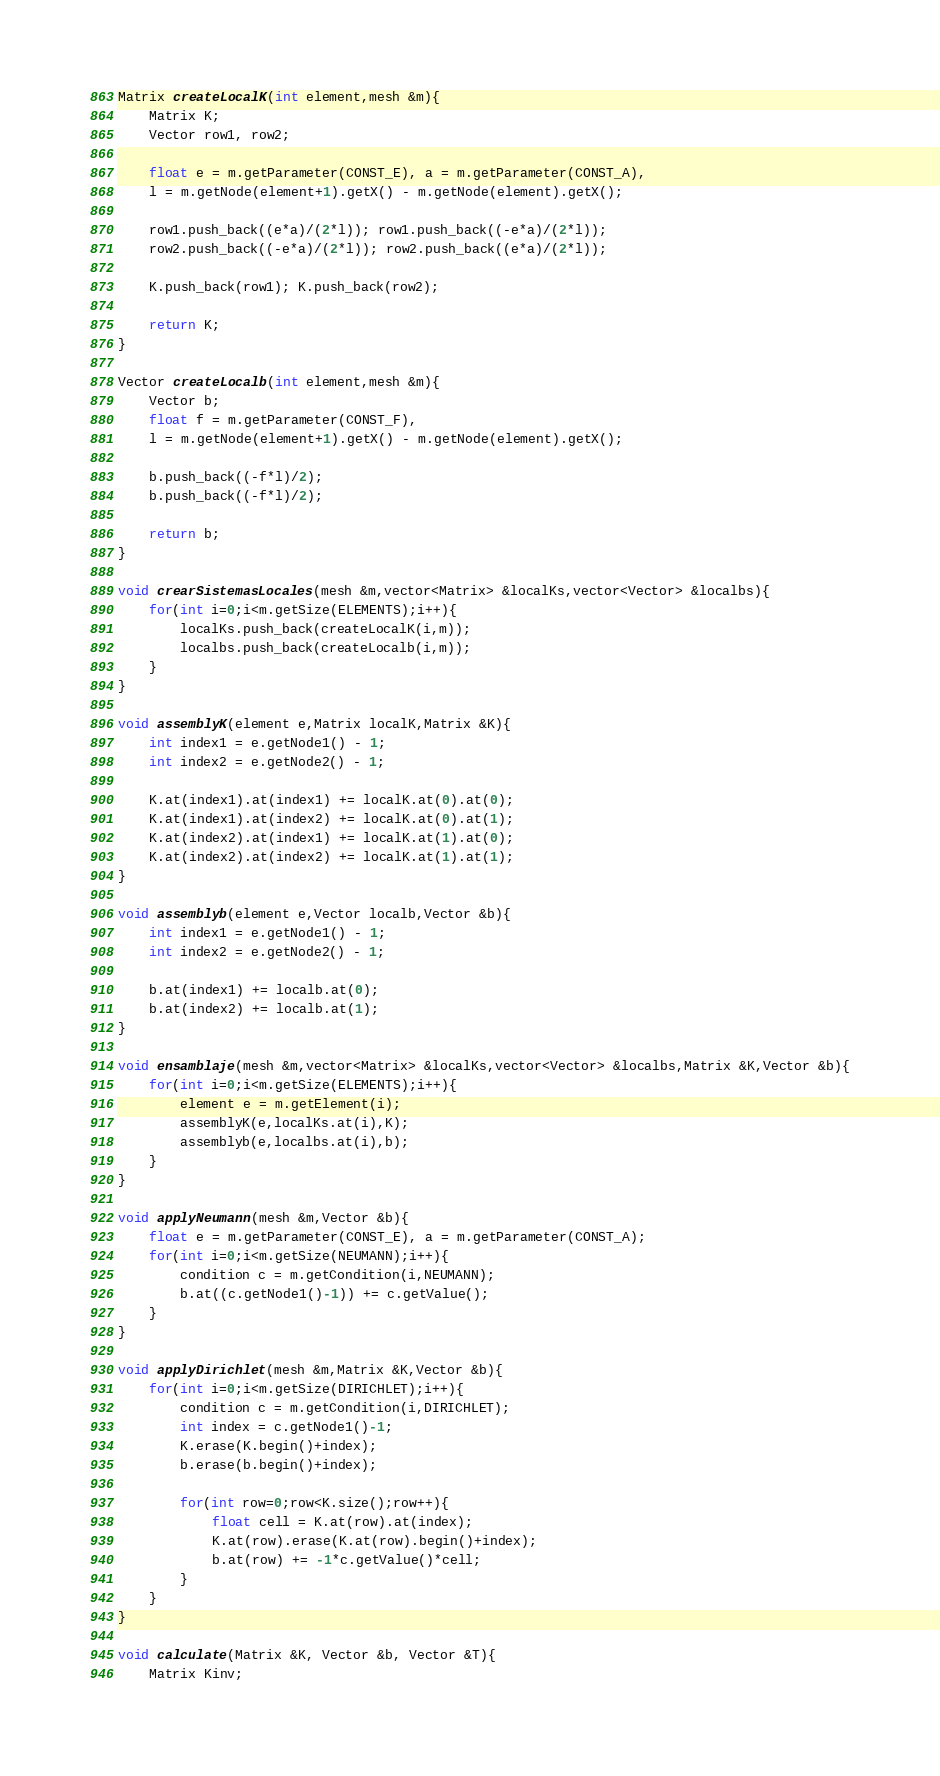Convert code to text. <code><loc_0><loc_0><loc_500><loc_500><_C_>Matrix createLocalK(int element,mesh &m){
    Matrix K;
    Vector row1, row2;

    float e = m.getParameter(CONST_E), a = m.getParameter(CONST_A),
    l = m.getNode(element+1).getX() - m.getNode(element).getX();
    
    row1.push_back((e*a)/(2*l)); row1.push_back((-e*a)/(2*l));
    row2.push_back((-e*a)/(2*l)); row2.push_back((e*a)/(2*l));
    
    K.push_back(row1); K.push_back(row2);

    return K;
}

Vector createLocalb(int element,mesh &m){
    Vector b;
    float f = m.getParameter(CONST_F),
    l = m.getNode(element+1).getX() - m.getNode(element).getX();
    
    b.push_back((-f*l)/2); 
    b.push_back((-f*l)/2);
    
    return b;
}

void crearSistemasLocales(mesh &m,vector<Matrix> &localKs,vector<Vector> &localbs){
    for(int i=0;i<m.getSize(ELEMENTS);i++){
        localKs.push_back(createLocalK(i,m));
        localbs.push_back(createLocalb(i,m));
    }
}

void assemblyK(element e,Matrix localK,Matrix &K){
    int index1 = e.getNode1() - 1;
    int index2 = e.getNode2() - 1;
    
    K.at(index1).at(index1) += localK.at(0).at(0);
    K.at(index1).at(index2) += localK.at(0).at(1);
    K.at(index2).at(index1) += localK.at(1).at(0);
    K.at(index2).at(index2) += localK.at(1).at(1);
}

void assemblyb(element e,Vector localb,Vector &b){
    int index1 = e.getNode1() - 1;
    int index2 = e.getNode2() - 1;
    
    b.at(index1) += localb.at(0);
    b.at(index2) += localb.at(1);
}

void ensamblaje(mesh &m,vector<Matrix> &localKs,vector<Vector> &localbs,Matrix &K,Vector &b){
    for(int i=0;i<m.getSize(ELEMENTS);i++){
        element e = m.getElement(i);
        assemblyK(e,localKs.at(i),K);
        assemblyb(e,localbs.at(i),b);
    }
}

void applyNeumann(mesh &m,Vector &b){
    float e = m.getParameter(CONST_E), a = m.getParameter(CONST_A);
    for(int i=0;i<m.getSize(NEUMANN);i++){
        condition c = m.getCondition(i,NEUMANN);
        b.at((c.getNode1()-1)) += c.getValue();
    }
}

void applyDirichlet(mesh &m,Matrix &K,Vector &b){
    for(int i=0;i<m.getSize(DIRICHLET);i++){
        condition c = m.getCondition(i,DIRICHLET);
        int index = c.getNode1()-1;
        K.erase(K.begin()+index);
        b.erase(b.begin()+index);

        for(int row=0;row<K.size();row++){
            float cell = K.at(row).at(index);
            K.at(row).erase(K.at(row).begin()+index);
            b.at(row) += -1*c.getValue()*cell;
        }
    }
}

void calculate(Matrix &K, Vector &b, Vector &T){
    Matrix Kinv;</code> 